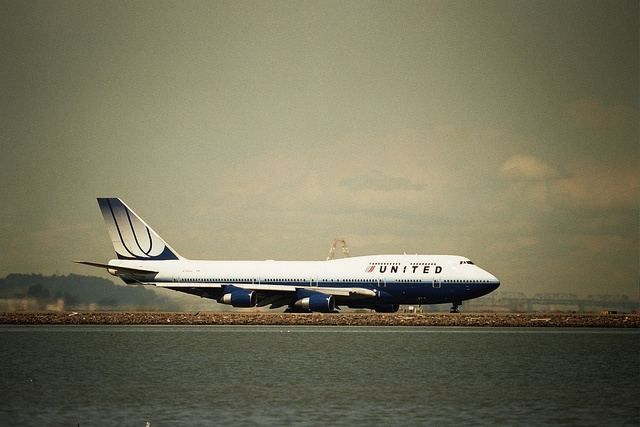Describe the objects in this image and their specific colors. I can see a airplane in darkgreen, ivory, black, beige, and gray tones in this image. 